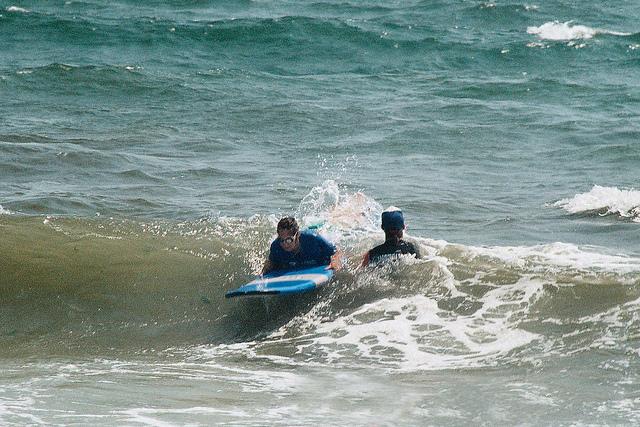What kind of boat is the man floating on?
Answer briefly. Surfboard. What are the different hues of the ocean found in this scene?
Keep it brief. Blue and green. Do they look like they're having fun?
Answer briefly. Yes. 